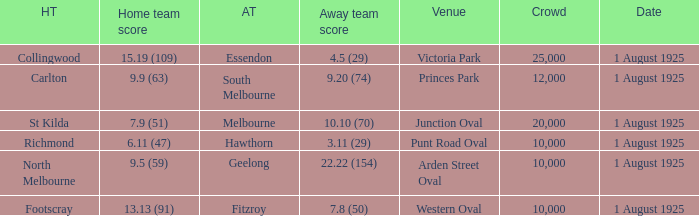When did the match take place that had a home team score of 7.9 (51)? 1 August 1925. 